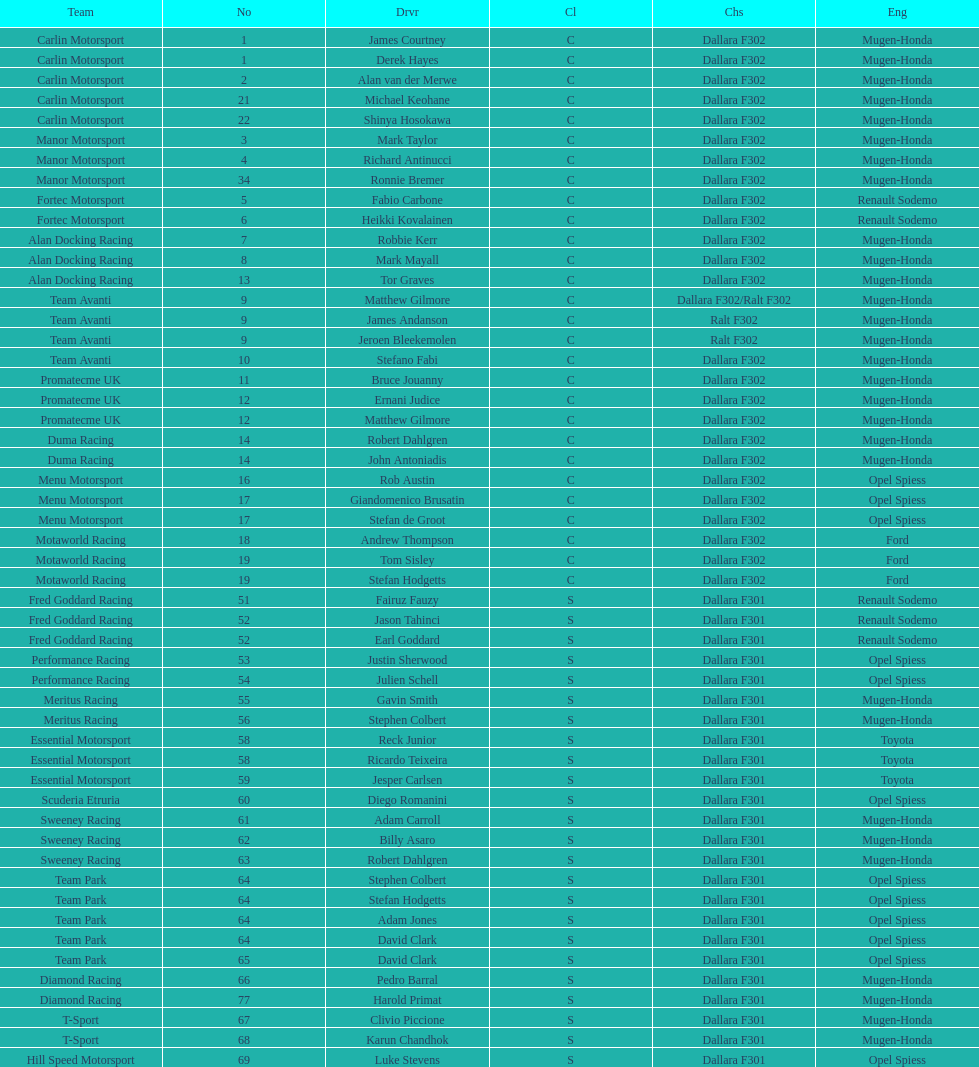What is the average number of teams that had a mugen-honda engine? 24. 